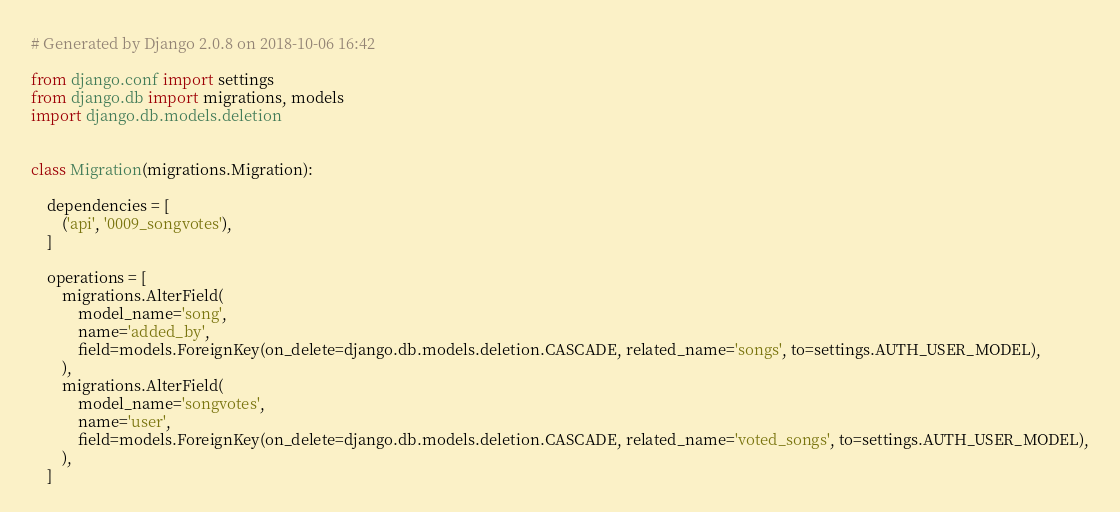<code> <loc_0><loc_0><loc_500><loc_500><_Python_># Generated by Django 2.0.8 on 2018-10-06 16:42

from django.conf import settings
from django.db import migrations, models
import django.db.models.deletion


class Migration(migrations.Migration):

    dependencies = [
        ('api', '0009_songvotes'),
    ]

    operations = [
        migrations.AlterField(
            model_name='song',
            name='added_by',
            field=models.ForeignKey(on_delete=django.db.models.deletion.CASCADE, related_name='songs', to=settings.AUTH_USER_MODEL),
        ),
        migrations.AlterField(
            model_name='songvotes',
            name='user',
            field=models.ForeignKey(on_delete=django.db.models.deletion.CASCADE, related_name='voted_songs', to=settings.AUTH_USER_MODEL),
        ),
    ]
</code> 